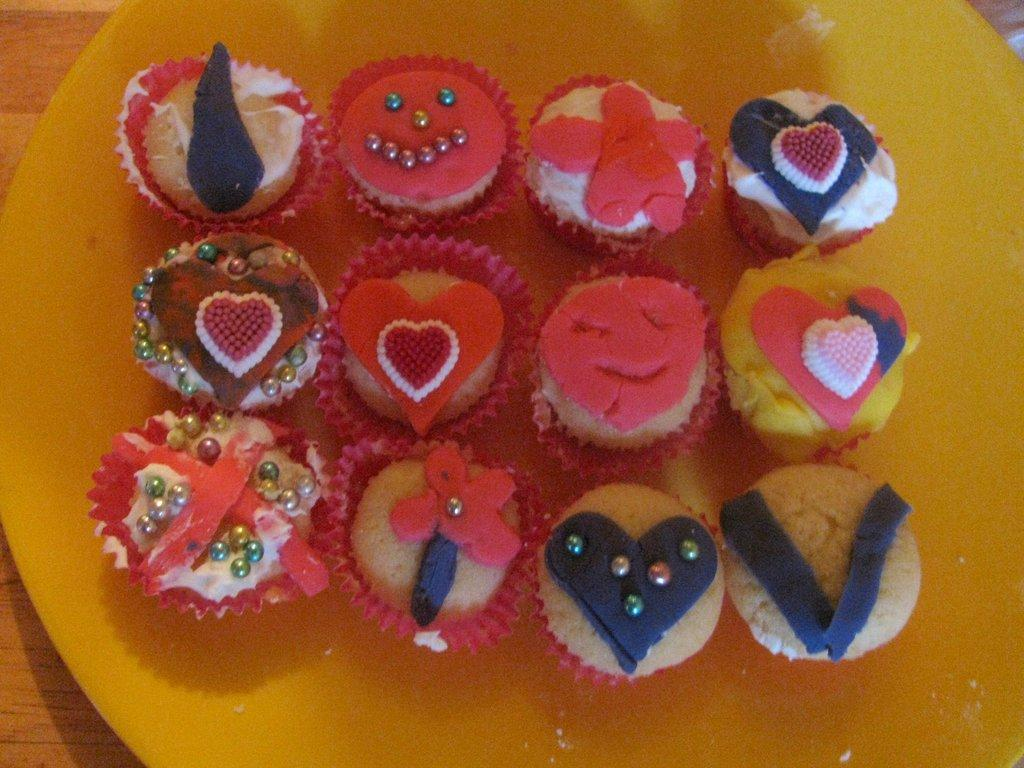What color is the plate in the image? The plate in the image is yellow. What is the plate placed on? The plate is on a brown and cream colored table. What type of food is on the plate? There are cupcakes on the plate. Can you see people playing in the park in the image? There is no park or people playing in the image; it only features a yellow plate with cupcakes on a brown and cream colored table. 